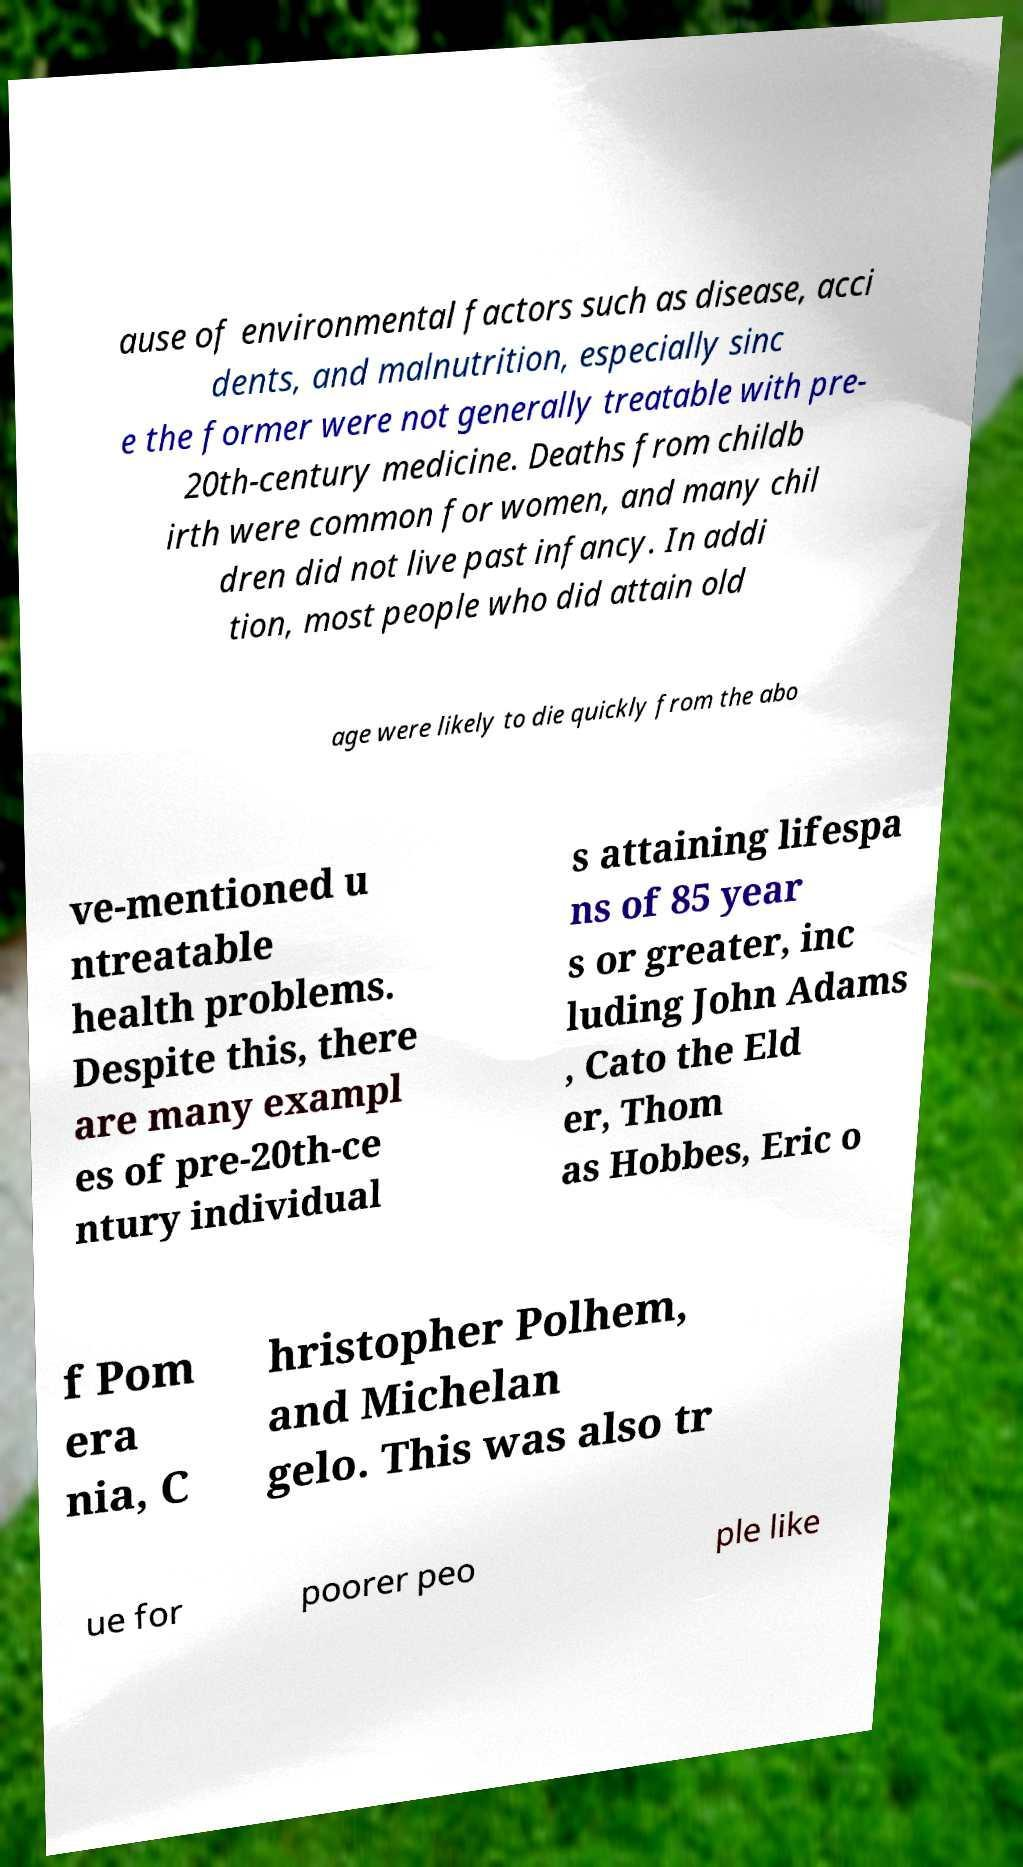There's text embedded in this image that I need extracted. Can you transcribe it verbatim? ause of environmental factors such as disease, acci dents, and malnutrition, especially sinc e the former were not generally treatable with pre- 20th-century medicine. Deaths from childb irth were common for women, and many chil dren did not live past infancy. In addi tion, most people who did attain old age were likely to die quickly from the abo ve-mentioned u ntreatable health problems. Despite this, there are many exampl es of pre-20th-ce ntury individual s attaining lifespa ns of 85 year s or greater, inc luding John Adams , Cato the Eld er, Thom as Hobbes, Eric o f Pom era nia, C hristopher Polhem, and Michelan gelo. This was also tr ue for poorer peo ple like 